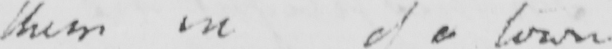Can you read and transcribe this handwriting? them inof a town 